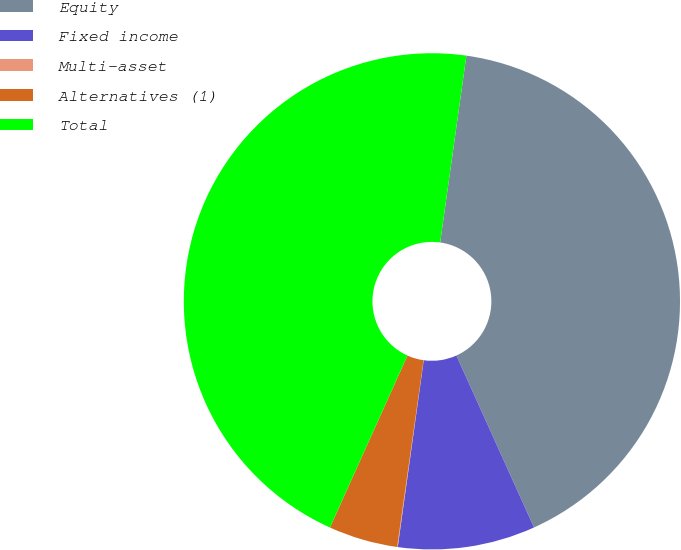Convert chart. <chart><loc_0><loc_0><loc_500><loc_500><pie_chart><fcel>Equity<fcel>Fixed income<fcel>Multi-asset<fcel>Alternatives (1)<fcel>Total<nl><fcel>41.03%<fcel>8.95%<fcel>0.04%<fcel>4.5%<fcel>45.48%<nl></chart> 